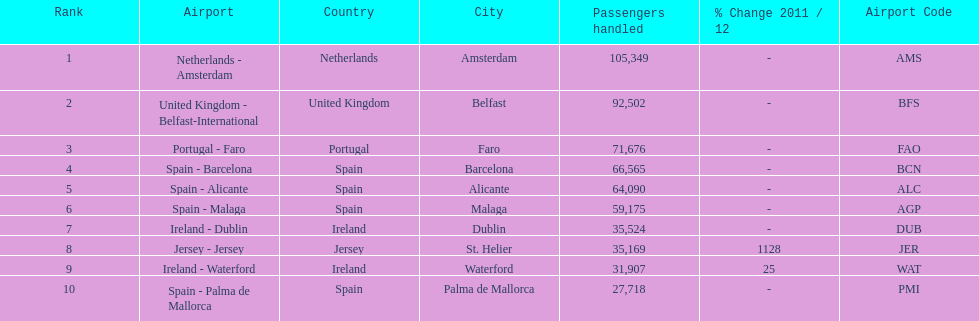Where is the most popular destination for passengers leaving london southend airport? Netherlands - Amsterdam. 